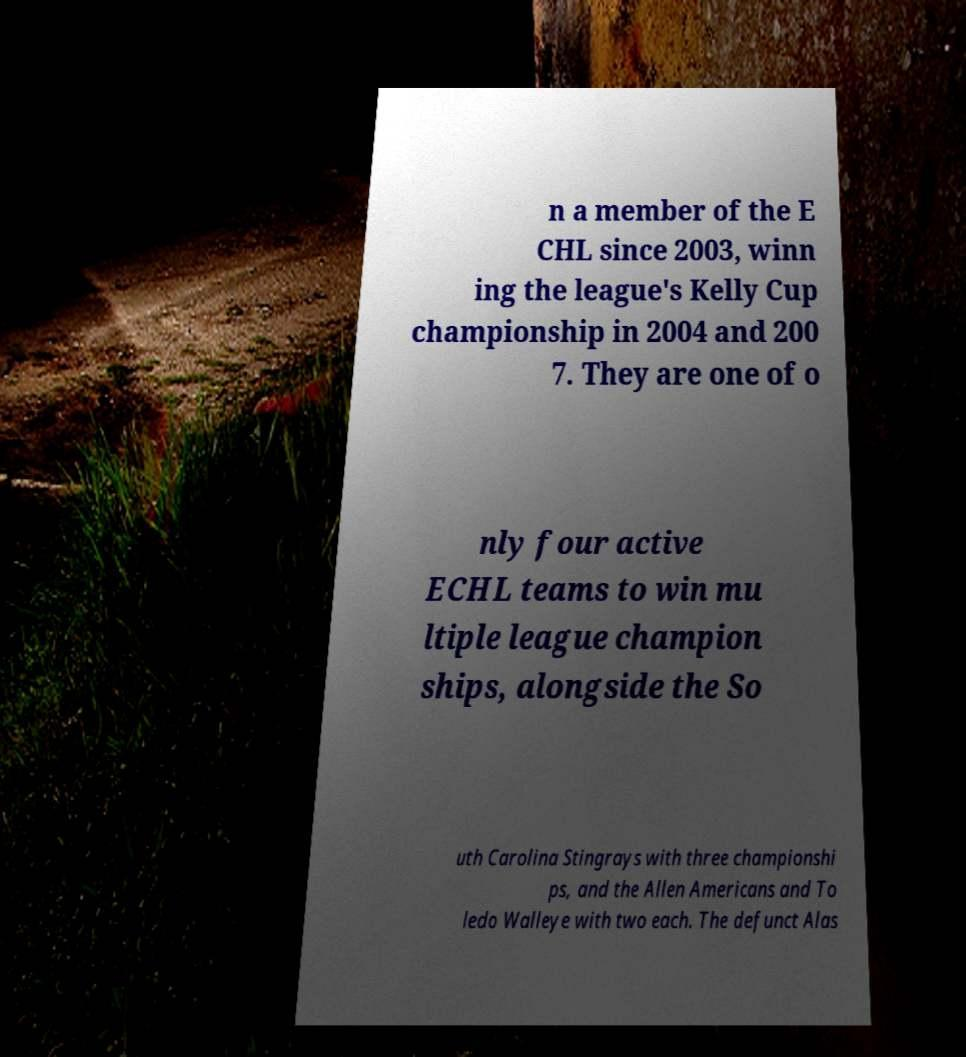There's text embedded in this image that I need extracted. Can you transcribe it verbatim? n a member of the E CHL since 2003, winn ing the league's Kelly Cup championship in 2004 and 200 7. They are one of o nly four active ECHL teams to win mu ltiple league champion ships, alongside the So uth Carolina Stingrays with three championshi ps, and the Allen Americans and To ledo Walleye with two each. The defunct Alas 